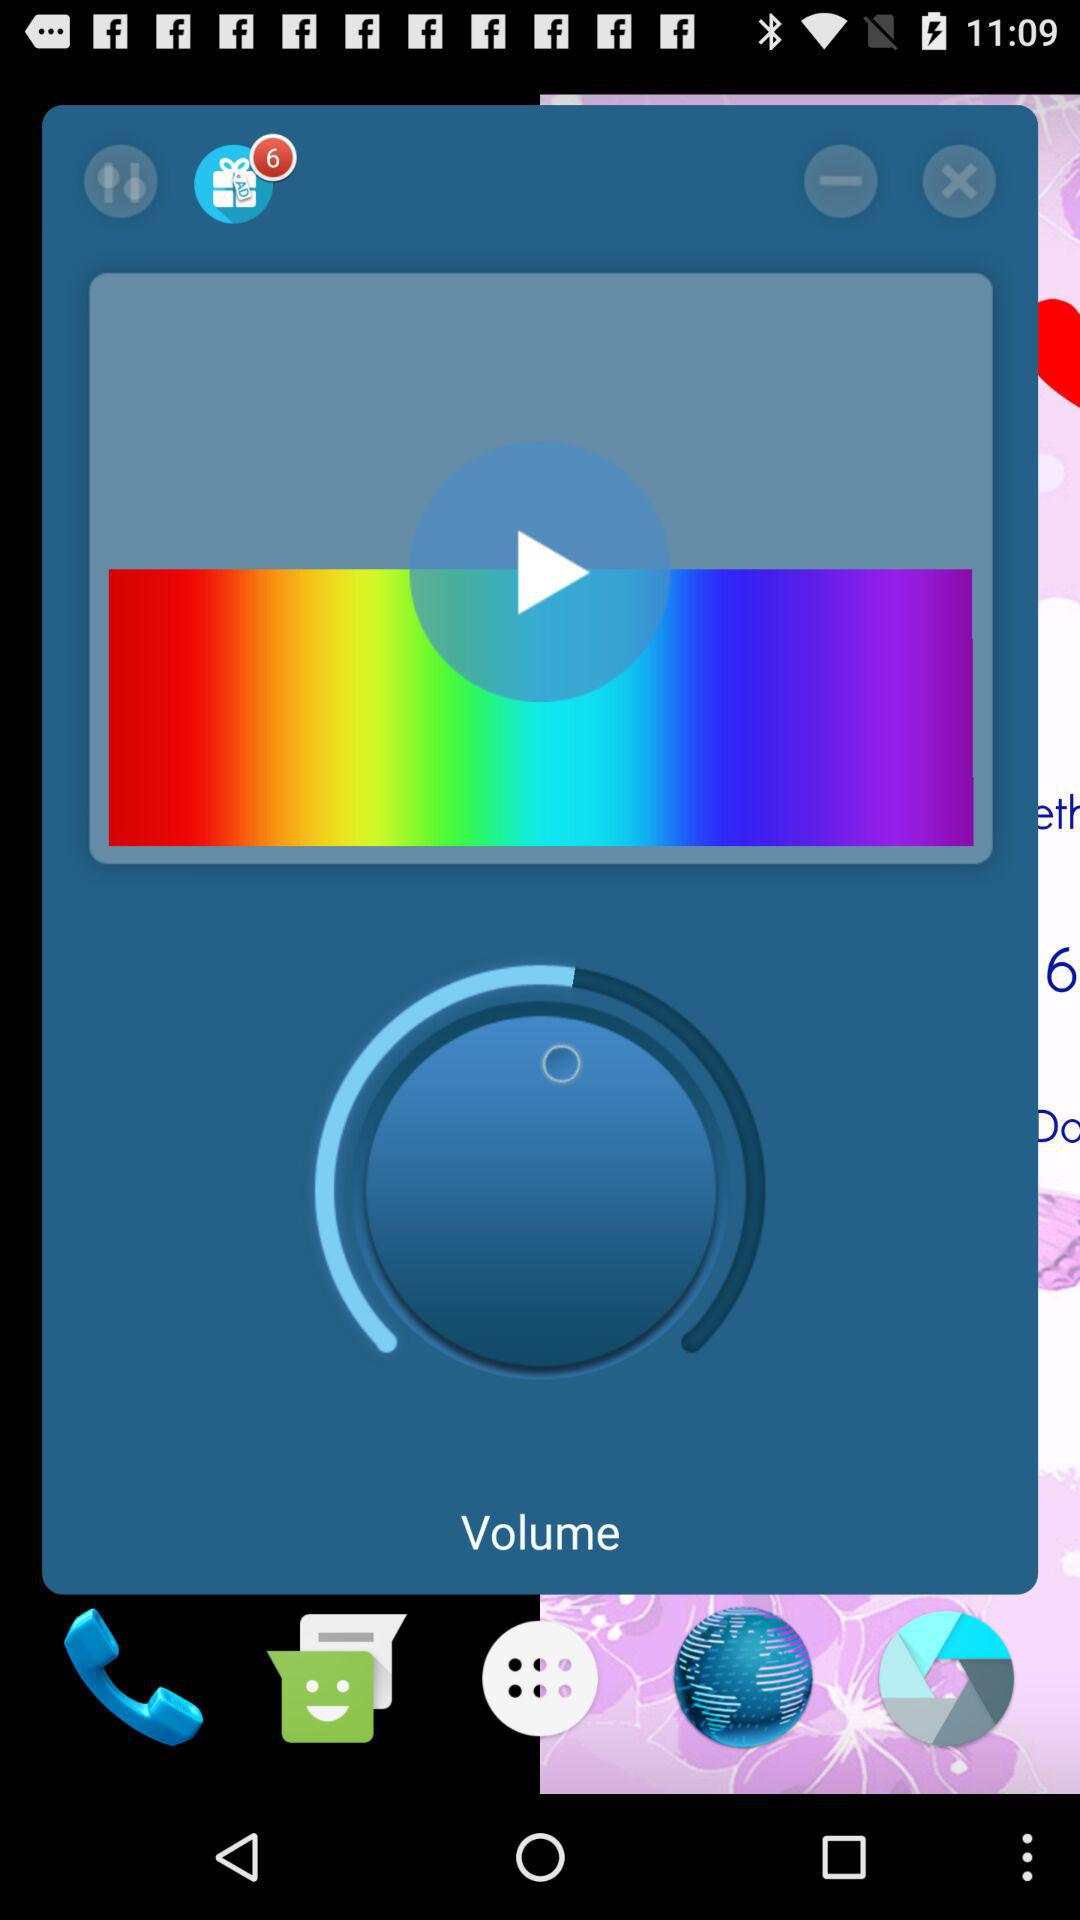Which function is performed?
When the provided information is insufficient, respond with <no answer>. <no answer> 